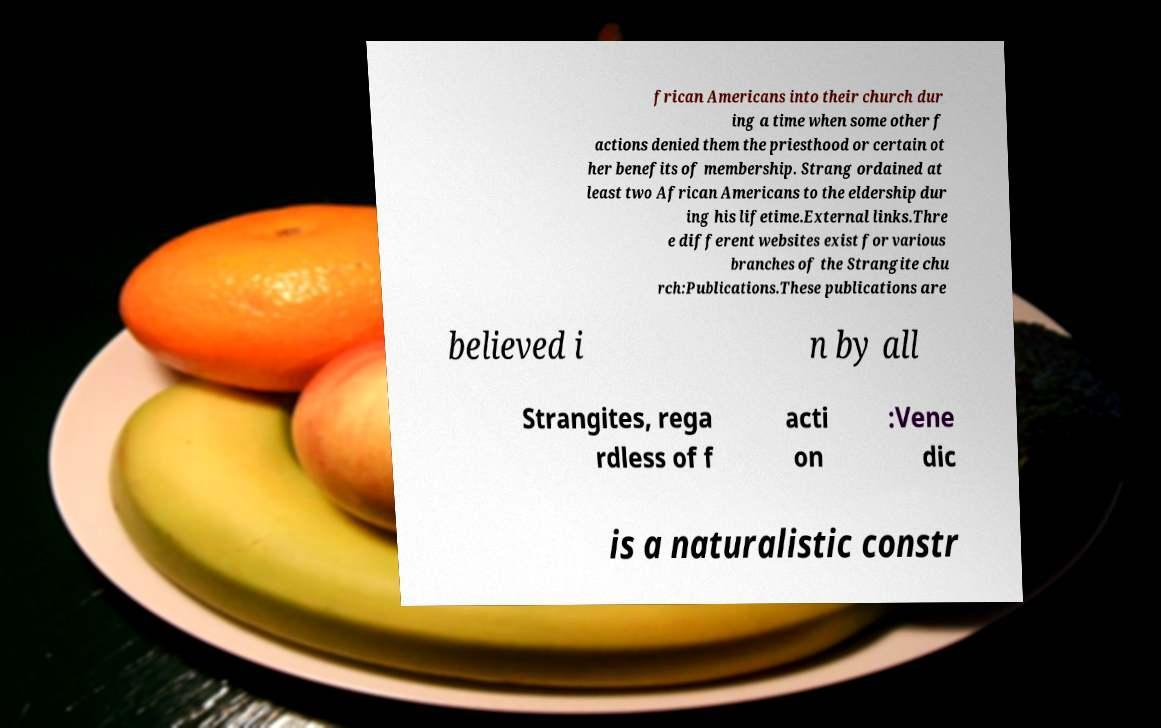For documentation purposes, I need the text within this image transcribed. Could you provide that? frican Americans into their church dur ing a time when some other f actions denied them the priesthood or certain ot her benefits of membership. Strang ordained at least two African Americans to the eldership dur ing his lifetime.External links.Thre e different websites exist for various branches of the Strangite chu rch:Publications.These publications are believed i n by all Strangites, rega rdless of f acti on :Vene dic is a naturalistic constr 